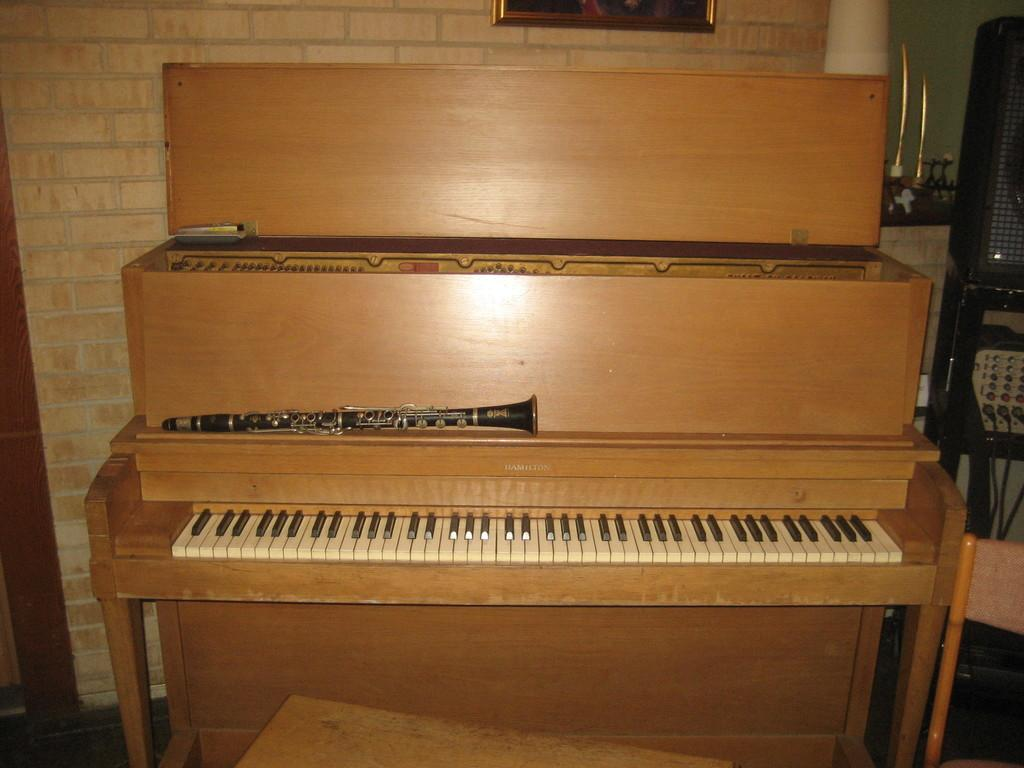What type of musical instrument is visible in the image? There is a piano keyboard in the image. What color is the piano keyboard? The piano keyboard is brown. Is the piano keyboard the main focus of the image? Yes, the piano keyboard is highlighted in the image. What else can be seen on the wall in the image? There is a picture on the wall. What is used for amplifying sound in the image? There is a speaker with a stand in the image. Can you see a rabbit playing the piano keyboard in the image? No, there is no rabbit present in the image, and the piano keyboard is not being played by any visible animal. 